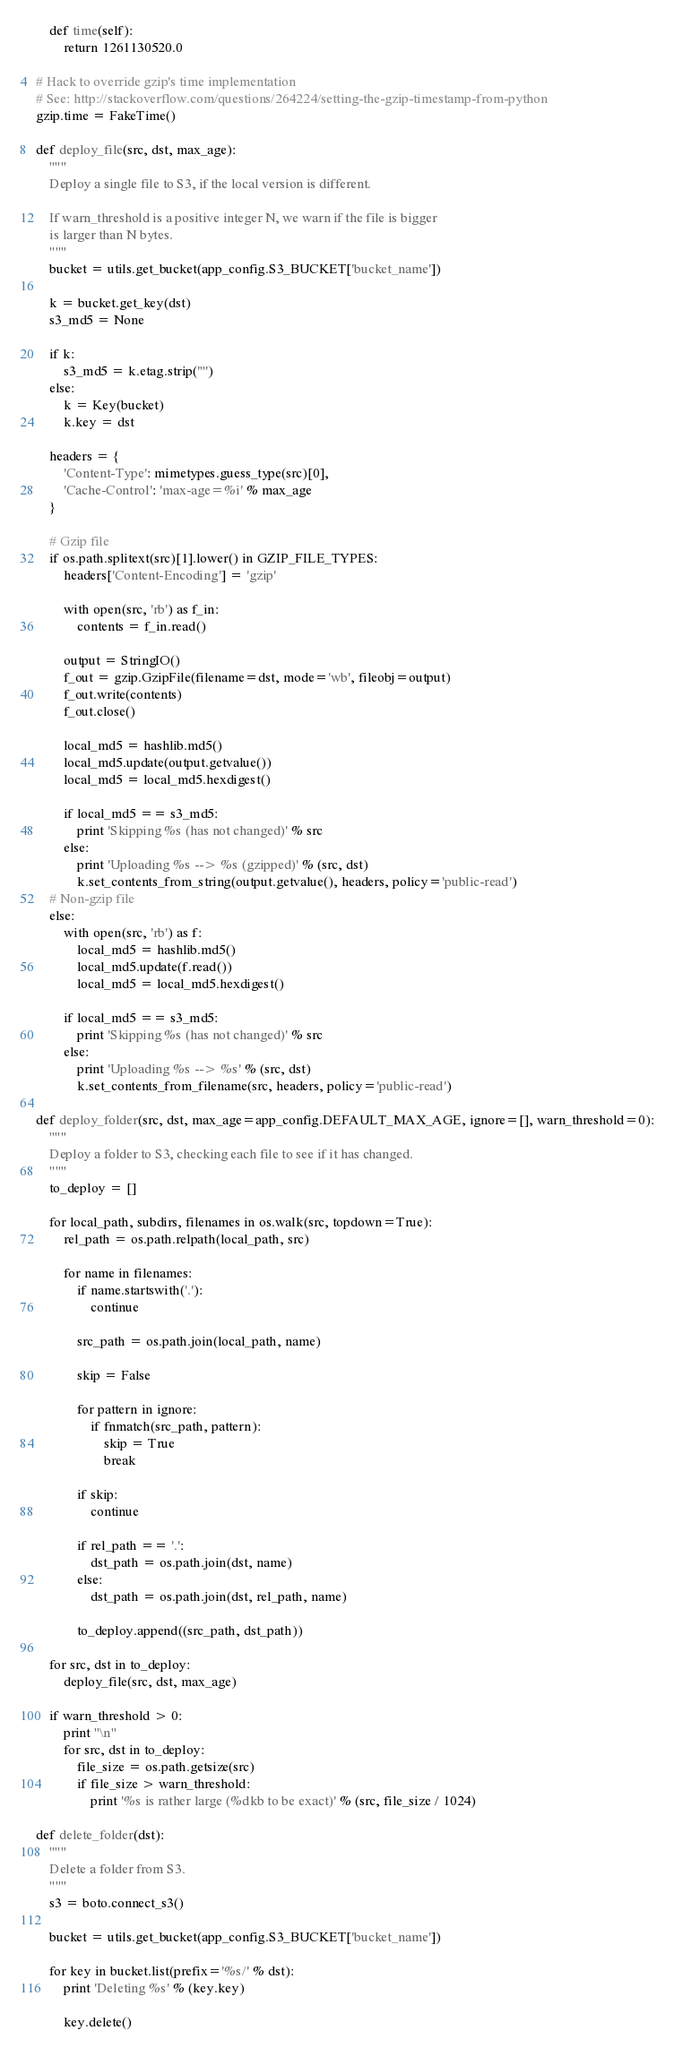<code> <loc_0><loc_0><loc_500><loc_500><_Python_>    def time(self):
        return 1261130520.0

# Hack to override gzip's time implementation
# See: http://stackoverflow.com/questions/264224/setting-the-gzip-timestamp-from-python
gzip.time = FakeTime()

def deploy_file(src, dst, max_age):
    """
    Deploy a single file to S3, if the local version is different.

    If warn_threshold is a positive integer N, we warn if the file is bigger
    is larger than N bytes.
    """
    bucket = utils.get_bucket(app_config.S3_BUCKET['bucket_name'])

    k = bucket.get_key(dst)
    s3_md5 = None

    if k:
        s3_md5 = k.etag.strip('"')
    else:
        k = Key(bucket)
        k.key = dst

    headers = {
        'Content-Type': mimetypes.guess_type(src)[0],
        'Cache-Control': 'max-age=%i' % max_age
    }

    # Gzip file
    if os.path.splitext(src)[1].lower() in GZIP_FILE_TYPES:
        headers['Content-Encoding'] = 'gzip'

        with open(src, 'rb') as f_in:
            contents = f_in.read()

        output = StringIO()
        f_out = gzip.GzipFile(filename=dst, mode='wb', fileobj=output)
        f_out.write(contents)
        f_out.close()

        local_md5 = hashlib.md5()
        local_md5.update(output.getvalue())
        local_md5 = local_md5.hexdigest()

        if local_md5 == s3_md5:
            print 'Skipping %s (has not changed)' % src
        else:
            print 'Uploading %s --> %s (gzipped)' % (src, dst)
            k.set_contents_from_string(output.getvalue(), headers, policy='public-read')
    # Non-gzip file
    else:
        with open(src, 'rb') as f:
            local_md5 = hashlib.md5()
            local_md5.update(f.read())
            local_md5 = local_md5.hexdigest()

        if local_md5 == s3_md5:
            print 'Skipping %s (has not changed)' % src
        else:
            print 'Uploading %s --> %s' % (src, dst)
            k.set_contents_from_filename(src, headers, policy='public-read')

def deploy_folder(src, dst, max_age=app_config.DEFAULT_MAX_AGE, ignore=[], warn_threshold=0):
    """
    Deploy a folder to S3, checking each file to see if it has changed.
    """
    to_deploy = []

    for local_path, subdirs, filenames in os.walk(src, topdown=True):
        rel_path = os.path.relpath(local_path, src)

        for name in filenames:
            if name.startswith('.'):
                continue

            src_path = os.path.join(local_path, name)

            skip = False

            for pattern in ignore:
                if fnmatch(src_path, pattern):
                    skip = True
                    break

            if skip:
                continue

            if rel_path == '.':
                dst_path = os.path.join(dst, name)
            else:
                dst_path = os.path.join(dst, rel_path, name)

            to_deploy.append((src_path, dst_path))

    for src, dst in to_deploy:
        deploy_file(src, dst, max_age)

    if warn_threshold > 0:
        print "\n"
        for src, dst in to_deploy:
            file_size = os.path.getsize(src)
            if file_size > warn_threshold:
                print '%s is rather large (%dkb to be exact)' % (src, file_size / 1024)

def delete_folder(dst):
    """
    Delete a folder from S3.
    """
    s3 = boto.connect_s3()

    bucket = utils.get_bucket(app_config.S3_BUCKET['bucket_name'])

    for key in bucket.list(prefix='%s/' % dst):
        print 'Deleting %s' % (key.key)

        key.delete()

</code> 